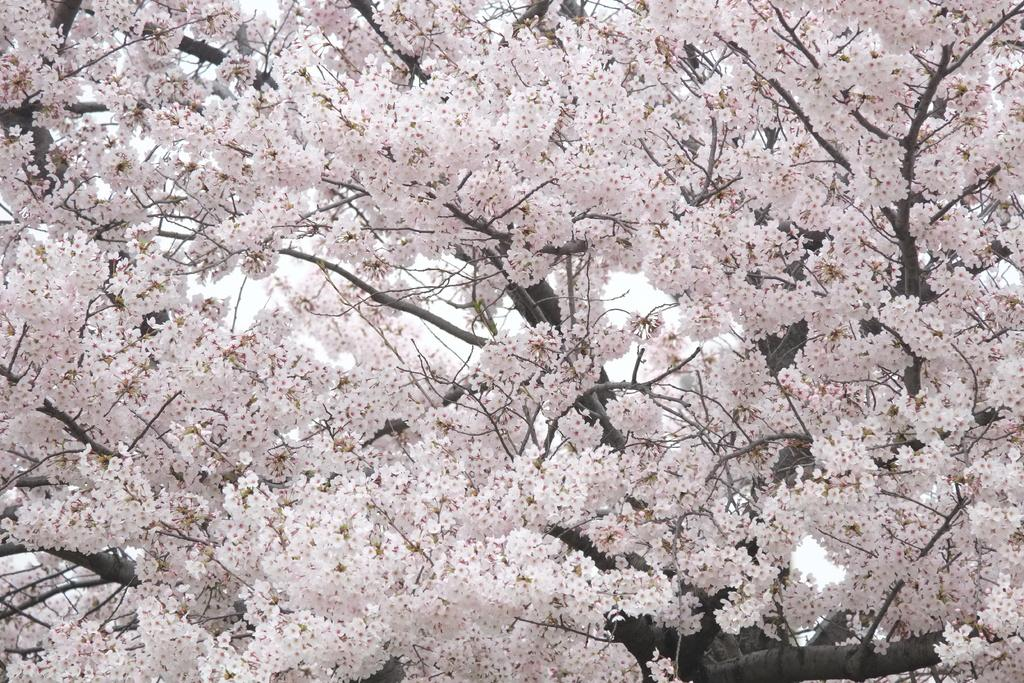What type of plants can be seen in the image? There are flowers and trees in the image. What color is the background of the image? The background of the image is white. Can you see a rat hiding among the flowers in the image? There is no rat present in the image. Is there a library visible in the background of the image? There is no library present in the image; the background is white. 